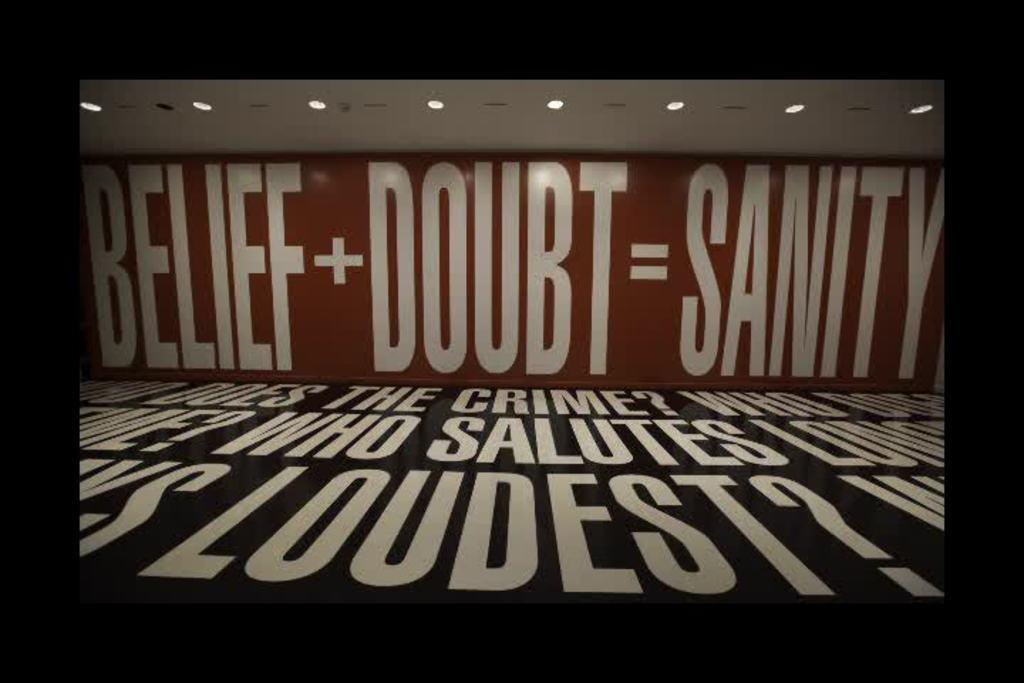<image>
Render a clear and concise summary of the photo. walls inside of a building that say 'belief+doubt=sanity' 